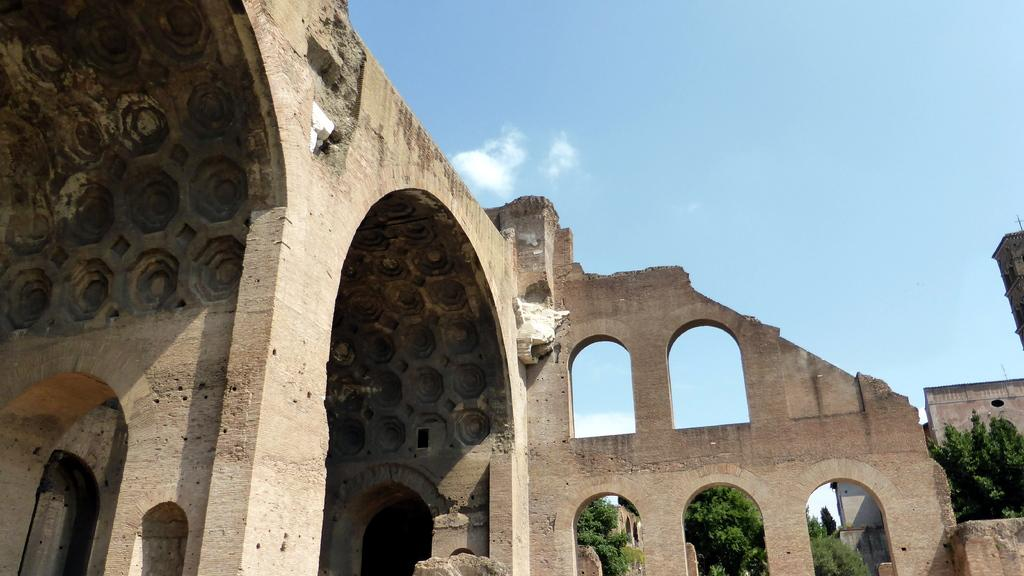What is the main structure in the middle of the image? There is a fort in the middle of the image. What type of vegetation is on the right side of the image? There are trees on the right side of the image. What is visible at the top of the image? The sky is visible at the top of the image. Can you see any ghosts or needles in the image? No, there are no ghosts or needles present in the image. What type of popcorn is being served at the fort in the image? There is no popcorn present in the image. 